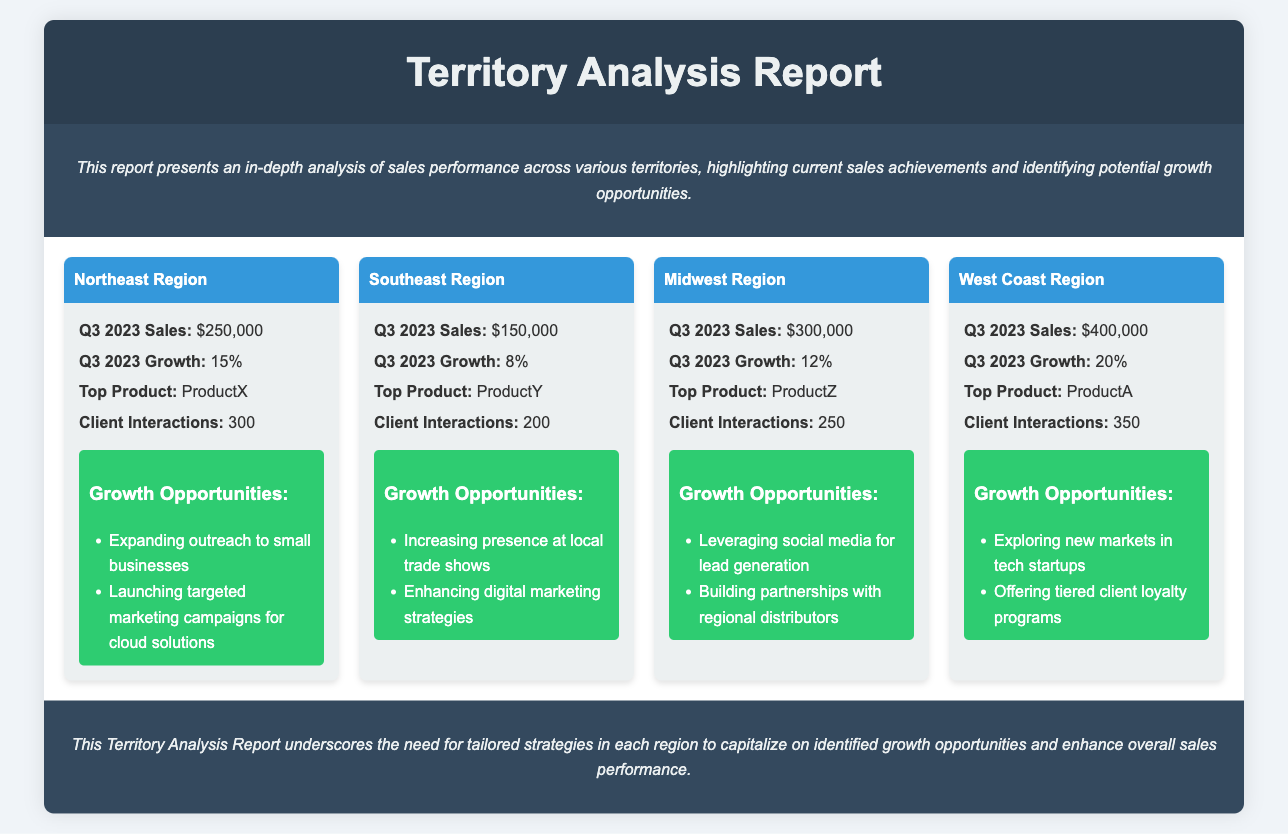what is the total sales for the Midwest Region? The total sales for the Midwest Region is specified as $300,000 in the document.
Answer: $300,000 which region had the highest growth percentage in Q3 2023? Upon comparing the growth percentages of all regions, the West Coast Region recorded the highest growth at 20%.
Answer: West Coast Region how many client interactions were recorded in the Northeast Region? The document states that there were 300 client interactions in the Northeast Region.
Answer: 300 what is the top product sold in the Southeast Region? According to the report, the top product for the Southeast Region is ProductY.
Answer: ProductY what growth opportunities are mentioned for the West Coast Region? The document lists two opportunities for the West Coast Region: exploring new markets in tech startups and offering tiered client loyalty programs.
Answer: Exploring new markets in tech startups; Offering tiered client loyalty programs how does the Q3 2023 sales of the Northeast Region compare to that of the Southeast Region? The Northeast Region's sales of $250,000 exceed the Southeast Region's sales of $150,000, indicating a stronger performance in the Northeast.
Answer: Northeast Region exceeds Southeast Region what overall strategy recommendation is provided in the conclusion? The conclusion suggests the need for tailored strategies in each region to take advantage of growth opportunities and improve sales performance.
Answer: Tailored strategies in each region how many total client interactions were recorded across all regions? By adding the client interactions from all regions (300 + 200 + 250 + 350), the total is calculated as 1,100 client interactions.
Answer: 1,100 